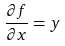<formula> <loc_0><loc_0><loc_500><loc_500>\frac { \partial f } { \partial x } = y</formula> 